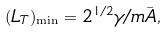Convert formula to latex. <formula><loc_0><loc_0><loc_500><loc_500>( L _ { T } ) _ { \min } = 2 ^ { 1 / 2 } \gamma / m \bar { A } ,</formula> 